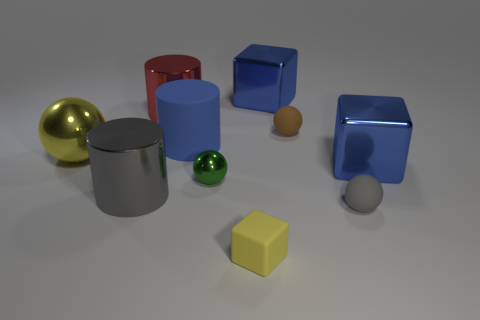What number of gray spheres are the same material as the big yellow object?
Give a very brief answer. 0. The tiny thing on the left side of the yellow thing right of the yellow object that is left of the matte block is what color?
Keep it short and to the point. Green. Is the size of the yellow block the same as the green shiny sphere?
Your answer should be very brief. Yes. What number of things are big blue things that are behind the big blue rubber cylinder or brown spheres?
Offer a very short reply. 2. Is the large red metal thing the same shape as the big matte object?
Provide a succinct answer. Yes. What number of other objects are there of the same size as the yellow block?
Ensure brevity in your answer.  3. What color is the big matte cylinder?
Ensure brevity in your answer.  Blue. What number of tiny objects are either blue cylinders or cyan metallic objects?
Your answer should be very brief. 0. There is a blue metallic thing that is to the right of the small gray sphere; does it have the same size as the metal object in front of the tiny green object?
Your answer should be compact. Yes. There is a green object that is the same shape as the yellow metal thing; what is its size?
Provide a short and direct response. Small. 